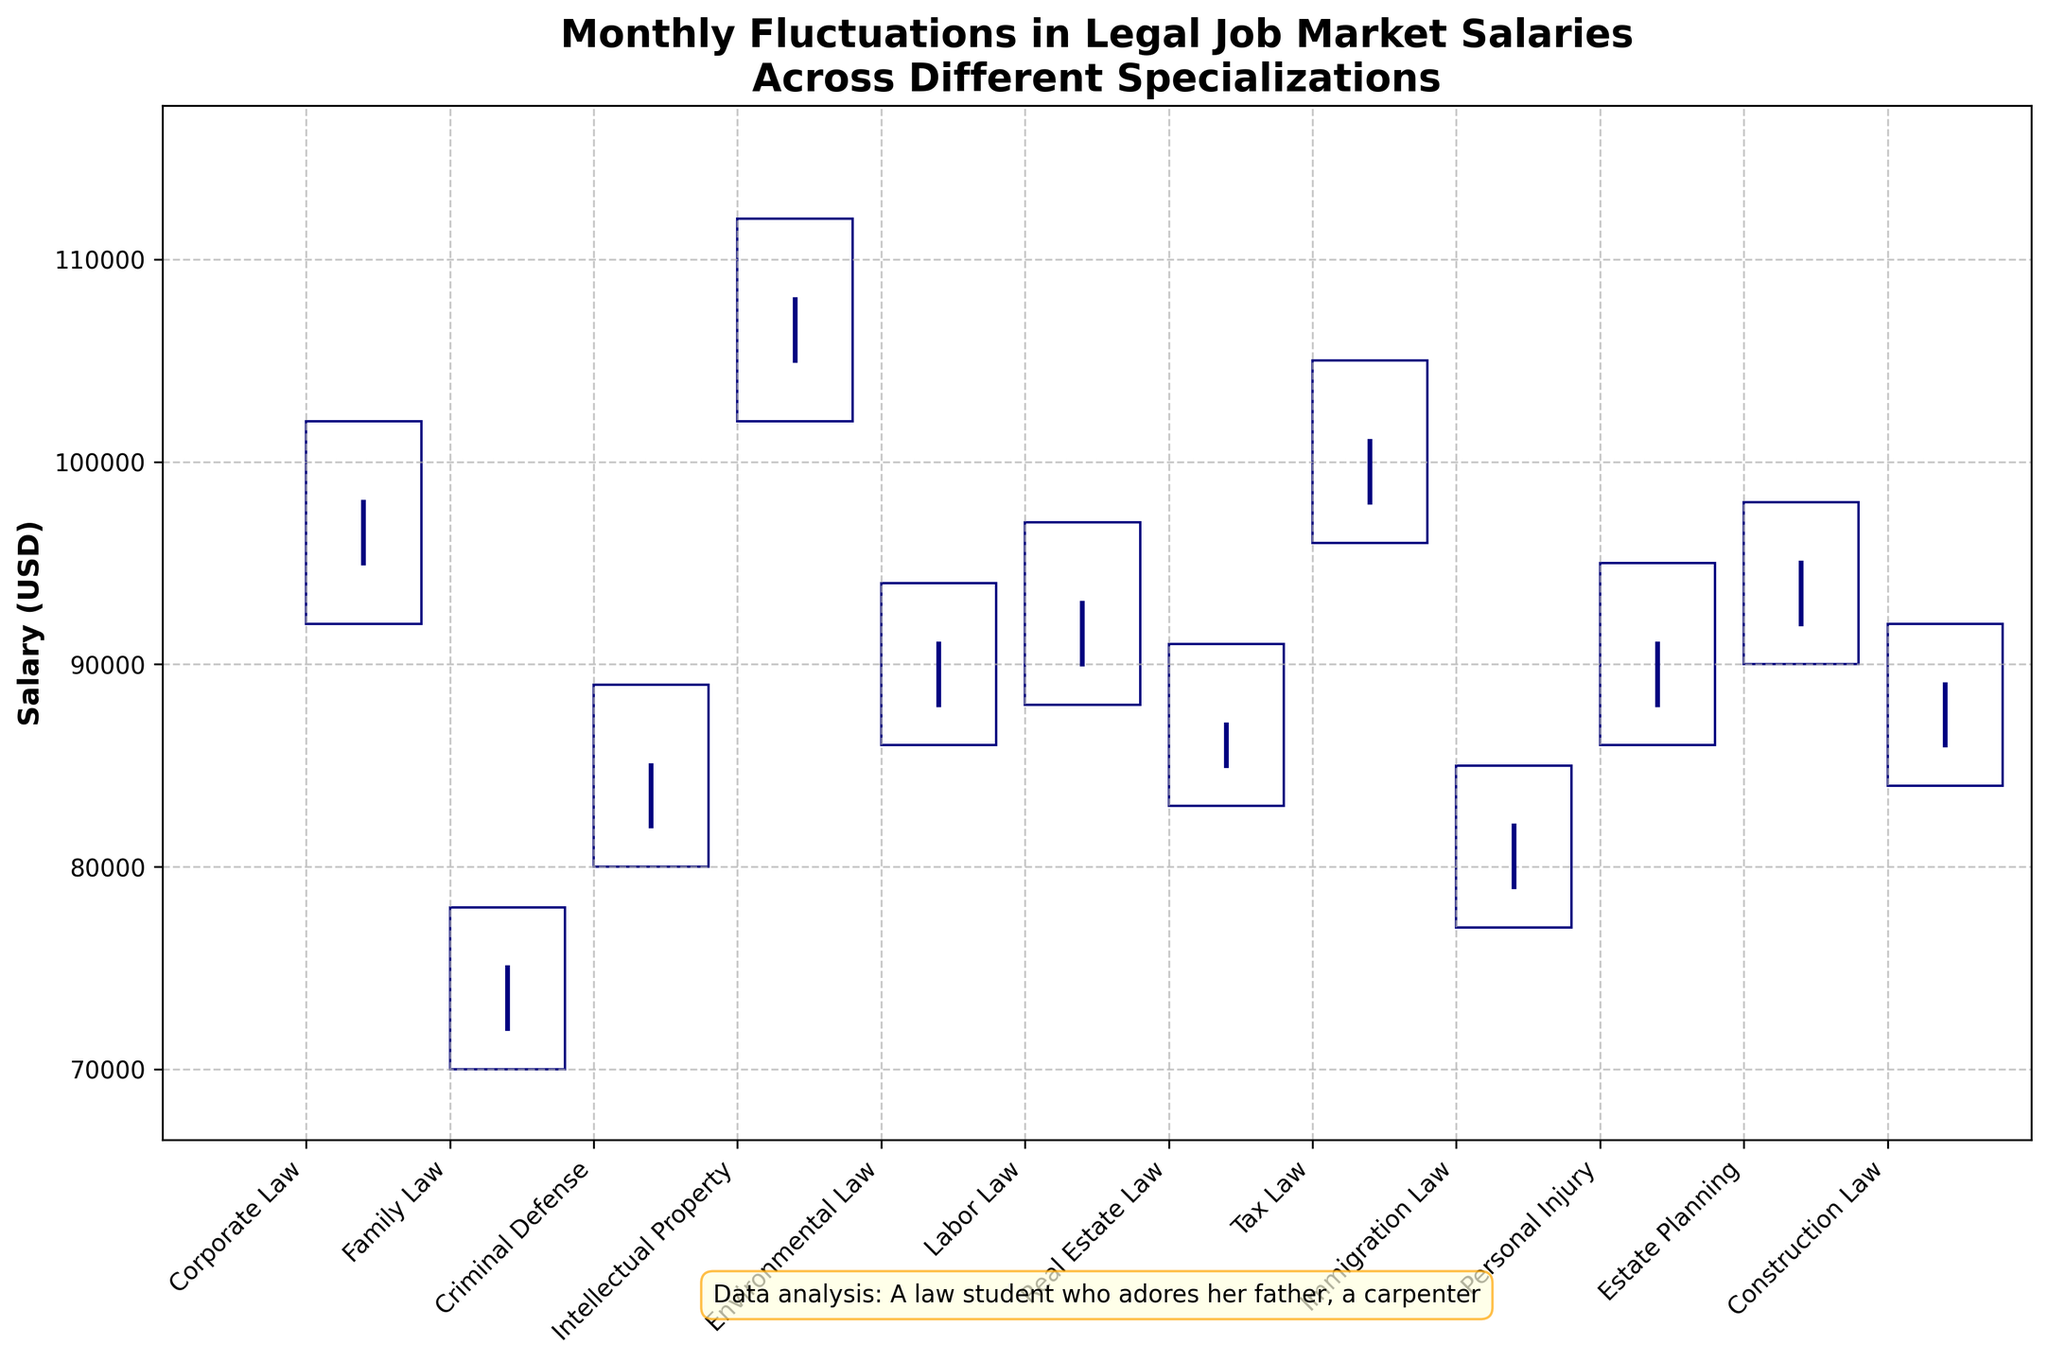What's the title of the chart? The title of the chart is typically found at the top of the figure and helps summarize what the chart is about. Looking at the visual, the title should be easily identifiable.
Answer: Monthly Fluctuations in Legal Job Market Salaries Across Different Specializations Which specialization has the highest closing salary? The "Close" column represents the closing salaries for each specialization, and by examining the visual bars or annotations, we can identify which one stands the highest.
Answer: Tax Law What is the range of salaries for Corporate Law in January 2023? The range is calculated by looking at the highest and lowest salary points for Corporate Law. According to the chart, the High is 102,000 and the Low is 92,000.
Answer: 10,000 How much did the salary increase for Labor Law from the opening in June 2023 to its high? To determine the increase, we need to subtract the opening salary from the high. For Labor Law in June 2023, this would be 97,000 - 90,000.
Answer: 7,000 Which specialization had the greatest fluctuation in salary? The greatest fluctuation is found by identifying the specialization with the largest difference between its high and low salaries over the given period. By examining the visual bars, we find the specialization with the widest spread.
Answer: Intellectual Property What is the average closing salary for all specializations? To find the average, add up all the closing salaries and divide by the number of specializations. The values are 98,000, 75,000, 85,000, 108,000, 91,000, 93,000, 87,000, 101,000, 82,000, 91,000, 95,000, 89,000, and when summed, the total is 1,065,000. There are 12 specializations, so the average is 1,065,000 / 12.
Answer: 88,750 Which two specializations have the closest ending salaries? By comparing all the closing salaries visually, we look for the two values that are nearest to each other. Real Estate Law and Personal Injury both close at 91,000.
Answer: Real Estate Law and Personal Injury By how much did the closing salary in Corporate Law increase from January to December 2023? To find this, subtract the closing salary for Corporate Law in January from the closing salary in December. That is 98,000 - 89,000.
Answer: 9,000 Which specialization had the lowest opening salary, and what was it? The opening salary is shown by the Open data points. By comparing all these points visually, identify the one with the lowest value.
Answer: Family Law, 72,000 How many of the specializations had a closing salary higher than 90,000? By looking at the closing salaries for all specializations and counting those above 90,000, we get the answer. The specializations that close above 90,000 are Corporate Law, Intellectual Property, Environmental Law, Labor Law, Tax Law, Estate Planning, and Construction Law.
Answer: 7 